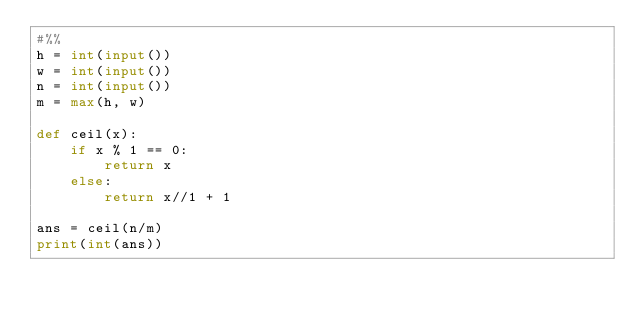<code> <loc_0><loc_0><loc_500><loc_500><_Python_>#%%
h = int(input())
w = int(input())
n = int(input())
m = max(h, w)

def ceil(x):
    if x % 1 == 0:
        return x
    else:
        return x//1 + 1

ans = ceil(n/m)
print(int(ans))</code> 